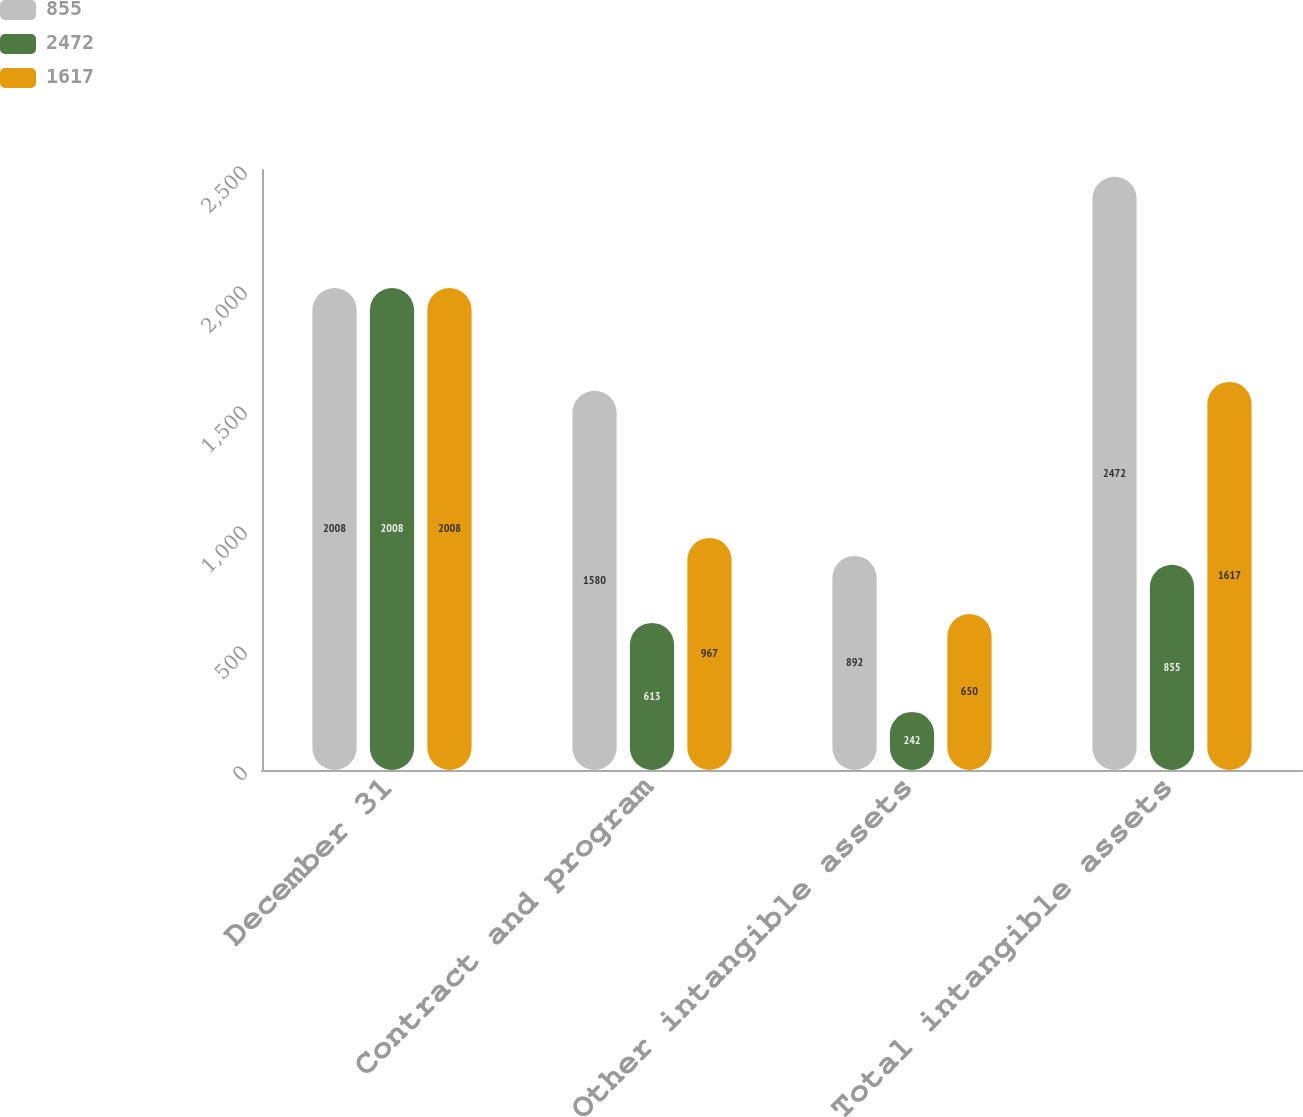Convert chart. <chart><loc_0><loc_0><loc_500><loc_500><stacked_bar_chart><ecel><fcel>December 31<fcel>Contract and program<fcel>Other intangible assets<fcel>Total intangible assets<nl><fcel>855<fcel>2008<fcel>1580<fcel>892<fcel>2472<nl><fcel>2472<fcel>2008<fcel>613<fcel>242<fcel>855<nl><fcel>1617<fcel>2008<fcel>967<fcel>650<fcel>1617<nl></chart> 